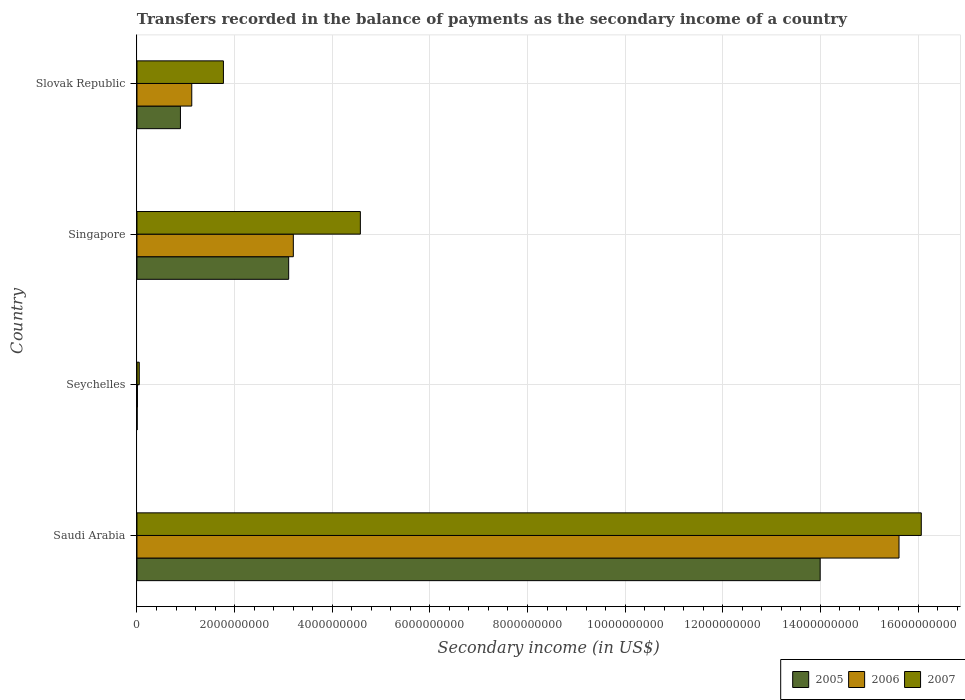How many different coloured bars are there?
Provide a short and direct response. 3. How many groups of bars are there?
Your answer should be compact. 4. Are the number of bars per tick equal to the number of legend labels?
Offer a terse response. Yes. Are the number of bars on each tick of the Y-axis equal?
Your answer should be very brief. Yes. How many bars are there on the 3rd tick from the top?
Provide a short and direct response. 3. What is the label of the 3rd group of bars from the top?
Provide a succinct answer. Seychelles. In how many cases, is the number of bars for a given country not equal to the number of legend labels?
Offer a terse response. 0. What is the secondary income of in 2005 in Saudi Arabia?
Offer a terse response. 1.40e+1. Across all countries, what is the maximum secondary income of in 2005?
Provide a succinct answer. 1.40e+1. Across all countries, what is the minimum secondary income of in 2005?
Give a very brief answer. 3.99e+06. In which country was the secondary income of in 2006 maximum?
Give a very brief answer. Saudi Arabia. In which country was the secondary income of in 2006 minimum?
Your answer should be very brief. Seychelles. What is the total secondary income of in 2007 in the graph?
Provide a succinct answer. 2.25e+1. What is the difference between the secondary income of in 2005 in Seychelles and that in Slovak Republic?
Give a very brief answer. -8.87e+08. What is the difference between the secondary income of in 2006 in Saudi Arabia and the secondary income of in 2007 in Seychelles?
Ensure brevity in your answer.  1.56e+1. What is the average secondary income of in 2006 per country?
Keep it short and to the point. 4.99e+09. What is the difference between the secondary income of in 2005 and secondary income of in 2006 in Saudi Arabia?
Offer a very short reply. -1.62e+09. What is the ratio of the secondary income of in 2007 in Saudi Arabia to that in Singapore?
Provide a succinct answer. 3.51. Is the secondary income of in 2006 in Singapore less than that in Slovak Republic?
Provide a succinct answer. No. What is the difference between the highest and the second highest secondary income of in 2007?
Your answer should be compact. 1.15e+1. What is the difference between the highest and the lowest secondary income of in 2005?
Keep it short and to the point. 1.40e+1. What does the 1st bar from the top in Slovak Republic represents?
Make the answer very short. 2007. Is it the case that in every country, the sum of the secondary income of in 2007 and secondary income of in 2006 is greater than the secondary income of in 2005?
Keep it short and to the point. Yes. What is the difference between two consecutive major ticks on the X-axis?
Ensure brevity in your answer.  2.00e+09. Does the graph contain grids?
Your response must be concise. Yes. How are the legend labels stacked?
Provide a short and direct response. Horizontal. What is the title of the graph?
Your response must be concise. Transfers recorded in the balance of payments as the secondary income of a country. Does "1993" appear as one of the legend labels in the graph?
Your answer should be very brief. No. What is the label or title of the X-axis?
Provide a succinct answer. Secondary income (in US$). What is the label or title of the Y-axis?
Offer a terse response. Country. What is the Secondary income (in US$) in 2005 in Saudi Arabia?
Your answer should be very brief. 1.40e+1. What is the Secondary income (in US$) in 2006 in Saudi Arabia?
Provide a short and direct response. 1.56e+1. What is the Secondary income (in US$) of 2007 in Saudi Arabia?
Provide a short and direct response. 1.61e+1. What is the Secondary income (in US$) in 2005 in Seychelles?
Ensure brevity in your answer.  3.99e+06. What is the Secondary income (in US$) in 2006 in Seychelles?
Keep it short and to the point. 9.75e+06. What is the Secondary income (in US$) in 2007 in Seychelles?
Your answer should be compact. 4.69e+07. What is the Secondary income (in US$) in 2005 in Singapore?
Provide a short and direct response. 3.11e+09. What is the Secondary income (in US$) in 2006 in Singapore?
Keep it short and to the point. 3.20e+09. What is the Secondary income (in US$) of 2007 in Singapore?
Make the answer very short. 4.58e+09. What is the Secondary income (in US$) of 2005 in Slovak Republic?
Provide a short and direct response. 8.91e+08. What is the Secondary income (in US$) in 2006 in Slovak Republic?
Your response must be concise. 1.12e+09. What is the Secondary income (in US$) of 2007 in Slovak Republic?
Offer a terse response. 1.77e+09. Across all countries, what is the maximum Secondary income (in US$) in 2005?
Give a very brief answer. 1.40e+1. Across all countries, what is the maximum Secondary income (in US$) in 2006?
Make the answer very short. 1.56e+1. Across all countries, what is the maximum Secondary income (in US$) in 2007?
Provide a short and direct response. 1.61e+1. Across all countries, what is the minimum Secondary income (in US$) of 2005?
Ensure brevity in your answer.  3.99e+06. Across all countries, what is the minimum Secondary income (in US$) in 2006?
Make the answer very short. 9.75e+06. Across all countries, what is the minimum Secondary income (in US$) of 2007?
Your answer should be very brief. 4.69e+07. What is the total Secondary income (in US$) of 2005 in the graph?
Offer a very short reply. 1.80e+1. What is the total Secondary income (in US$) of 2006 in the graph?
Your answer should be compact. 1.99e+1. What is the total Secondary income (in US$) in 2007 in the graph?
Keep it short and to the point. 2.25e+1. What is the difference between the Secondary income (in US$) in 2005 in Saudi Arabia and that in Seychelles?
Keep it short and to the point. 1.40e+1. What is the difference between the Secondary income (in US$) in 2006 in Saudi Arabia and that in Seychelles?
Offer a very short reply. 1.56e+1. What is the difference between the Secondary income (in US$) of 2007 in Saudi Arabia and that in Seychelles?
Make the answer very short. 1.60e+1. What is the difference between the Secondary income (in US$) of 2005 in Saudi Arabia and that in Singapore?
Give a very brief answer. 1.09e+1. What is the difference between the Secondary income (in US$) of 2006 in Saudi Arabia and that in Singapore?
Your answer should be very brief. 1.24e+1. What is the difference between the Secondary income (in US$) in 2007 in Saudi Arabia and that in Singapore?
Ensure brevity in your answer.  1.15e+1. What is the difference between the Secondary income (in US$) in 2005 in Saudi Arabia and that in Slovak Republic?
Ensure brevity in your answer.  1.31e+1. What is the difference between the Secondary income (in US$) in 2006 in Saudi Arabia and that in Slovak Republic?
Offer a very short reply. 1.45e+1. What is the difference between the Secondary income (in US$) in 2007 in Saudi Arabia and that in Slovak Republic?
Your answer should be compact. 1.43e+1. What is the difference between the Secondary income (in US$) in 2005 in Seychelles and that in Singapore?
Offer a terse response. -3.10e+09. What is the difference between the Secondary income (in US$) in 2006 in Seychelles and that in Singapore?
Provide a succinct answer. -3.19e+09. What is the difference between the Secondary income (in US$) of 2007 in Seychelles and that in Singapore?
Ensure brevity in your answer.  -4.53e+09. What is the difference between the Secondary income (in US$) of 2005 in Seychelles and that in Slovak Republic?
Ensure brevity in your answer.  -8.87e+08. What is the difference between the Secondary income (in US$) in 2006 in Seychelles and that in Slovak Republic?
Ensure brevity in your answer.  -1.11e+09. What is the difference between the Secondary income (in US$) of 2007 in Seychelles and that in Slovak Republic?
Provide a short and direct response. -1.72e+09. What is the difference between the Secondary income (in US$) in 2005 in Singapore and that in Slovak Republic?
Offer a very short reply. 2.22e+09. What is the difference between the Secondary income (in US$) of 2006 in Singapore and that in Slovak Republic?
Offer a very short reply. 2.08e+09. What is the difference between the Secondary income (in US$) of 2007 in Singapore and that in Slovak Republic?
Keep it short and to the point. 2.81e+09. What is the difference between the Secondary income (in US$) in 2005 in Saudi Arabia and the Secondary income (in US$) in 2006 in Seychelles?
Your response must be concise. 1.40e+1. What is the difference between the Secondary income (in US$) in 2005 in Saudi Arabia and the Secondary income (in US$) in 2007 in Seychelles?
Keep it short and to the point. 1.39e+1. What is the difference between the Secondary income (in US$) of 2006 in Saudi Arabia and the Secondary income (in US$) of 2007 in Seychelles?
Offer a terse response. 1.56e+1. What is the difference between the Secondary income (in US$) in 2005 in Saudi Arabia and the Secondary income (in US$) in 2006 in Singapore?
Provide a succinct answer. 1.08e+1. What is the difference between the Secondary income (in US$) in 2005 in Saudi Arabia and the Secondary income (in US$) in 2007 in Singapore?
Provide a succinct answer. 9.42e+09. What is the difference between the Secondary income (in US$) of 2006 in Saudi Arabia and the Secondary income (in US$) of 2007 in Singapore?
Keep it short and to the point. 1.10e+1. What is the difference between the Secondary income (in US$) of 2005 in Saudi Arabia and the Secondary income (in US$) of 2006 in Slovak Republic?
Your answer should be very brief. 1.29e+1. What is the difference between the Secondary income (in US$) in 2005 in Saudi Arabia and the Secondary income (in US$) in 2007 in Slovak Republic?
Your response must be concise. 1.22e+1. What is the difference between the Secondary income (in US$) of 2006 in Saudi Arabia and the Secondary income (in US$) of 2007 in Slovak Republic?
Ensure brevity in your answer.  1.38e+1. What is the difference between the Secondary income (in US$) in 2005 in Seychelles and the Secondary income (in US$) in 2006 in Singapore?
Ensure brevity in your answer.  -3.20e+09. What is the difference between the Secondary income (in US$) of 2005 in Seychelles and the Secondary income (in US$) of 2007 in Singapore?
Keep it short and to the point. -4.57e+09. What is the difference between the Secondary income (in US$) of 2006 in Seychelles and the Secondary income (in US$) of 2007 in Singapore?
Give a very brief answer. -4.57e+09. What is the difference between the Secondary income (in US$) in 2005 in Seychelles and the Secondary income (in US$) in 2006 in Slovak Republic?
Your answer should be very brief. -1.12e+09. What is the difference between the Secondary income (in US$) of 2005 in Seychelles and the Secondary income (in US$) of 2007 in Slovak Republic?
Provide a succinct answer. -1.77e+09. What is the difference between the Secondary income (in US$) of 2006 in Seychelles and the Secondary income (in US$) of 2007 in Slovak Republic?
Offer a very short reply. -1.76e+09. What is the difference between the Secondary income (in US$) of 2005 in Singapore and the Secondary income (in US$) of 2006 in Slovak Republic?
Make the answer very short. 1.99e+09. What is the difference between the Secondary income (in US$) in 2005 in Singapore and the Secondary income (in US$) in 2007 in Slovak Republic?
Your answer should be compact. 1.34e+09. What is the difference between the Secondary income (in US$) of 2006 in Singapore and the Secondary income (in US$) of 2007 in Slovak Republic?
Your answer should be compact. 1.43e+09. What is the average Secondary income (in US$) in 2005 per country?
Your answer should be compact. 4.50e+09. What is the average Secondary income (in US$) of 2006 per country?
Your answer should be compact. 4.99e+09. What is the average Secondary income (in US$) of 2007 per country?
Ensure brevity in your answer.  5.62e+09. What is the difference between the Secondary income (in US$) of 2005 and Secondary income (in US$) of 2006 in Saudi Arabia?
Your response must be concise. -1.62e+09. What is the difference between the Secondary income (in US$) in 2005 and Secondary income (in US$) in 2007 in Saudi Arabia?
Your response must be concise. -2.07e+09. What is the difference between the Secondary income (in US$) in 2006 and Secondary income (in US$) in 2007 in Saudi Arabia?
Ensure brevity in your answer.  -4.56e+08. What is the difference between the Secondary income (in US$) of 2005 and Secondary income (in US$) of 2006 in Seychelles?
Keep it short and to the point. -5.75e+06. What is the difference between the Secondary income (in US$) in 2005 and Secondary income (in US$) in 2007 in Seychelles?
Ensure brevity in your answer.  -4.29e+07. What is the difference between the Secondary income (in US$) in 2006 and Secondary income (in US$) in 2007 in Seychelles?
Ensure brevity in your answer.  -3.72e+07. What is the difference between the Secondary income (in US$) of 2005 and Secondary income (in US$) of 2006 in Singapore?
Provide a short and direct response. -9.54e+07. What is the difference between the Secondary income (in US$) of 2005 and Secondary income (in US$) of 2007 in Singapore?
Keep it short and to the point. -1.47e+09. What is the difference between the Secondary income (in US$) in 2006 and Secondary income (in US$) in 2007 in Singapore?
Your answer should be very brief. -1.37e+09. What is the difference between the Secondary income (in US$) of 2005 and Secondary income (in US$) of 2006 in Slovak Republic?
Make the answer very short. -2.32e+08. What is the difference between the Secondary income (in US$) in 2005 and Secondary income (in US$) in 2007 in Slovak Republic?
Provide a short and direct response. -8.81e+08. What is the difference between the Secondary income (in US$) in 2006 and Secondary income (in US$) in 2007 in Slovak Republic?
Your response must be concise. -6.49e+08. What is the ratio of the Secondary income (in US$) in 2005 in Saudi Arabia to that in Seychelles?
Give a very brief answer. 3503.45. What is the ratio of the Secondary income (in US$) in 2006 in Saudi Arabia to that in Seychelles?
Keep it short and to the point. 1601.86. What is the ratio of the Secondary income (in US$) of 2007 in Saudi Arabia to that in Seychelles?
Your response must be concise. 342.26. What is the ratio of the Secondary income (in US$) of 2005 in Saudi Arabia to that in Singapore?
Your answer should be very brief. 4.5. What is the ratio of the Secondary income (in US$) in 2006 in Saudi Arabia to that in Singapore?
Offer a terse response. 4.87. What is the ratio of the Secondary income (in US$) in 2007 in Saudi Arabia to that in Singapore?
Offer a terse response. 3.51. What is the ratio of the Secondary income (in US$) in 2005 in Saudi Arabia to that in Slovak Republic?
Make the answer very short. 15.71. What is the ratio of the Secondary income (in US$) of 2006 in Saudi Arabia to that in Slovak Republic?
Keep it short and to the point. 13.91. What is the ratio of the Secondary income (in US$) of 2007 in Saudi Arabia to that in Slovak Republic?
Your answer should be compact. 9.07. What is the ratio of the Secondary income (in US$) in 2005 in Seychelles to that in Singapore?
Keep it short and to the point. 0. What is the ratio of the Secondary income (in US$) of 2006 in Seychelles to that in Singapore?
Offer a very short reply. 0. What is the ratio of the Secondary income (in US$) in 2007 in Seychelles to that in Singapore?
Ensure brevity in your answer.  0.01. What is the ratio of the Secondary income (in US$) of 2005 in Seychelles to that in Slovak Republic?
Your response must be concise. 0. What is the ratio of the Secondary income (in US$) in 2006 in Seychelles to that in Slovak Republic?
Offer a terse response. 0.01. What is the ratio of the Secondary income (in US$) in 2007 in Seychelles to that in Slovak Republic?
Keep it short and to the point. 0.03. What is the ratio of the Secondary income (in US$) of 2005 in Singapore to that in Slovak Republic?
Your answer should be compact. 3.49. What is the ratio of the Secondary income (in US$) in 2006 in Singapore to that in Slovak Republic?
Keep it short and to the point. 2.85. What is the ratio of the Secondary income (in US$) in 2007 in Singapore to that in Slovak Republic?
Offer a very short reply. 2.58. What is the difference between the highest and the second highest Secondary income (in US$) of 2005?
Offer a very short reply. 1.09e+1. What is the difference between the highest and the second highest Secondary income (in US$) of 2006?
Your answer should be compact. 1.24e+1. What is the difference between the highest and the second highest Secondary income (in US$) of 2007?
Ensure brevity in your answer.  1.15e+1. What is the difference between the highest and the lowest Secondary income (in US$) in 2005?
Offer a very short reply. 1.40e+1. What is the difference between the highest and the lowest Secondary income (in US$) in 2006?
Your answer should be compact. 1.56e+1. What is the difference between the highest and the lowest Secondary income (in US$) in 2007?
Your response must be concise. 1.60e+1. 